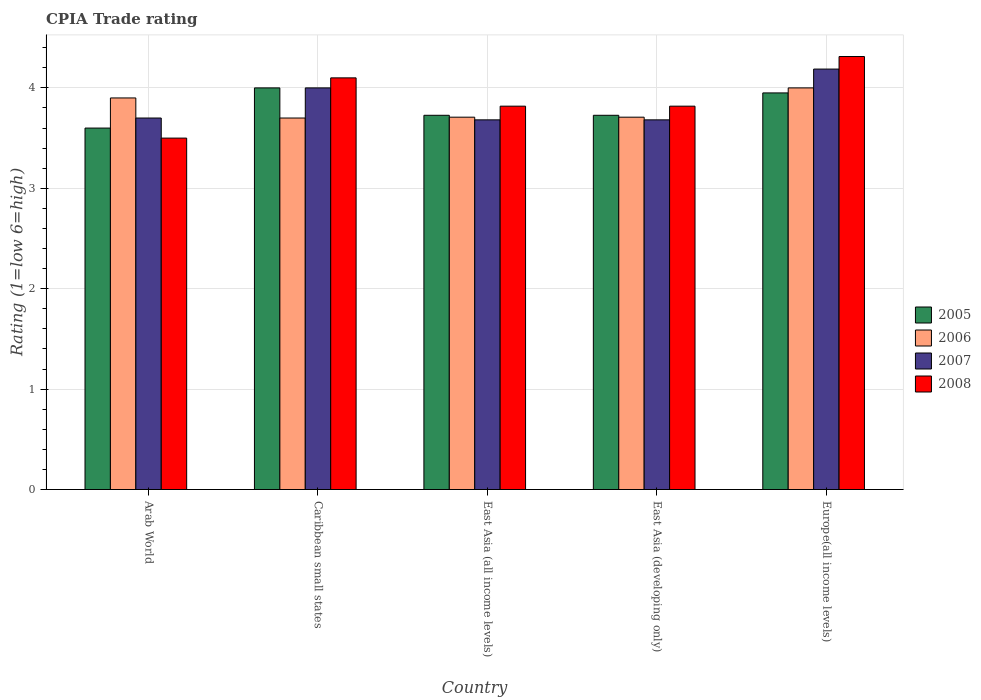How many groups of bars are there?
Offer a very short reply. 5. Are the number of bars on each tick of the X-axis equal?
Give a very brief answer. Yes. What is the label of the 4th group of bars from the left?
Give a very brief answer. East Asia (developing only). Across all countries, what is the minimum CPIA rating in 2007?
Provide a short and direct response. 3.68. In which country was the CPIA rating in 2007 maximum?
Provide a short and direct response. Europe(all income levels). In which country was the CPIA rating in 2008 minimum?
Ensure brevity in your answer.  Arab World. What is the total CPIA rating in 2006 in the graph?
Give a very brief answer. 19.02. What is the difference between the CPIA rating in 2005 in Arab World and that in Caribbean small states?
Keep it short and to the point. -0.4. What is the difference between the CPIA rating in 2008 in East Asia (all income levels) and the CPIA rating in 2007 in Caribbean small states?
Your response must be concise. -0.18. What is the average CPIA rating in 2005 per country?
Keep it short and to the point. 3.8. What is the difference between the CPIA rating of/in 2007 and CPIA rating of/in 2006 in Arab World?
Your answer should be very brief. -0.2. In how many countries, is the CPIA rating in 2006 greater than 3.6?
Keep it short and to the point. 5. What is the ratio of the CPIA rating in 2006 in Caribbean small states to that in Europe(all income levels)?
Offer a terse response. 0.93. Is the CPIA rating in 2007 in East Asia (all income levels) less than that in East Asia (developing only)?
Ensure brevity in your answer.  No. Is the difference between the CPIA rating in 2007 in Arab World and East Asia (developing only) greater than the difference between the CPIA rating in 2006 in Arab World and East Asia (developing only)?
Your response must be concise. No. What is the difference between the highest and the second highest CPIA rating in 2007?
Offer a very short reply. -0.49. What is the difference between the highest and the lowest CPIA rating in 2006?
Provide a succinct answer. 0.3. In how many countries, is the CPIA rating in 2006 greater than the average CPIA rating in 2006 taken over all countries?
Make the answer very short. 2. Is it the case that in every country, the sum of the CPIA rating in 2007 and CPIA rating in 2008 is greater than the sum of CPIA rating in 2005 and CPIA rating in 2006?
Provide a short and direct response. No. Is it the case that in every country, the sum of the CPIA rating in 2005 and CPIA rating in 2008 is greater than the CPIA rating in 2007?
Offer a terse response. Yes. How many bars are there?
Make the answer very short. 20. How many countries are there in the graph?
Offer a terse response. 5. What is the difference between two consecutive major ticks on the Y-axis?
Offer a terse response. 1. Are the values on the major ticks of Y-axis written in scientific E-notation?
Your response must be concise. No. Does the graph contain any zero values?
Provide a succinct answer. No. Does the graph contain grids?
Your response must be concise. Yes. Where does the legend appear in the graph?
Keep it short and to the point. Center right. How are the legend labels stacked?
Your answer should be compact. Vertical. What is the title of the graph?
Keep it short and to the point. CPIA Trade rating. What is the label or title of the Y-axis?
Your answer should be compact. Rating (1=low 6=high). What is the Rating (1=low 6=high) in 2006 in Arab World?
Offer a terse response. 3.9. What is the Rating (1=low 6=high) of 2007 in Caribbean small states?
Your response must be concise. 4. What is the Rating (1=low 6=high) in 2008 in Caribbean small states?
Provide a succinct answer. 4.1. What is the Rating (1=low 6=high) in 2005 in East Asia (all income levels)?
Keep it short and to the point. 3.73. What is the Rating (1=low 6=high) in 2006 in East Asia (all income levels)?
Offer a terse response. 3.71. What is the Rating (1=low 6=high) of 2007 in East Asia (all income levels)?
Your response must be concise. 3.68. What is the Rating (1=low 6=high) of 2008 in East Asia (all income levels)?
Offer a terse response. 3.82. What is the Rating (1=low 6=high) in 2005 in East Asia (developing only)?
Provide a succinct answer. 3.73. What is the Rating (1=low 6=high) of 2006 in East Asia (developing only)?
Provide a short and direct response. 3.71. What is the Rating (1=low 6=high) of 2007 in East Asia (developing only)?
Your answer should be compact. 3.68. What is the Rating (1=low 6=high) of 2008 in East Asia (developing only)?
Give a very brief answer. 3.82. What is the Rating (1=low 6=high) of 2005 in Europe(all income levels)?
Your answer should be compact. 3.95. What is the Rating (1=low 6=high) in 2006 in Europe(all income levels)?
Make the answer very short. 4. What is the Rating (1=low 6=high) of 2007 in Europe(all income levels)?
Your response must be concise. 4.19. What is the Rating (1=low 6=high) in 2008 in Europe(all income levels)?
Offer a very short reply. 4.31. Across all countries, what is the maximum Rating (1=low 6=high) in 2007?
Ensure brevity in your answer.  4.19. Across all countries, what is the maximum Rating (1=low 6=high) of 2008?
Give a very brief answer. 4.31. Across all countries, what is the minimum Rating (1=low 6=high) of 2005?
Ensure brevity in your answer.  3.6. Across all countries, what is the minimum Rating (1=low 6=high) of 2007?
Keep it short and to the point. 3.68. What is the total Rating (1=low 6=high) in 2005 in the graph?
Provide a succinct answer. 19. What is the total Rating (1=low 6=high) in 2006 in the graph?
Your answer should be compact. 19.02. What is the total Rating (1=low 6=high) in 2007 in the graph?
Give a very brief answer. 19.25. What is the total Rating (1=low 6=high) of 2008 in the graph?
Keep it short and to the point. 19.55. What is the difference between the Rating (1=low 6=high) of 2006 in Arab World and that in Caribbean small states?
Provide a short and direct response. 0.2. What is the difference between the Rating (1=low 6=high) in 2005 in Arab World and that in East Asia (all income levels)?
Make the answer very short. -0.13. What is the difference between the Rating (1=low 6=high) of 2006 in Arab World and that in East Asia (all income levels)?
Offer a terse response. 0.19. What is the difference between the Rating (1=low 6=high) of 2007 in Arab World and that in East Asia (all income levels)?
Provide a short and direct response. 0.02. What is the difference between the Rating (1=low 6=high) in 2008 in Arab World and that in East Asia (all income levels)?
Your answer should be compact. -0.32. What is the difference between the Rating (1=low 6=high) in 2005 in Arab World and that in East Asia (developing only)?
Your response must be concise. -0.13. What is the difference between the Rating (1=low 6=high) of 2006 in Arab World and that in East Asia (developing only)?
Make the answer very short. 0.19. What is the difference between the Rating (1=low 6=high) in 2007 in Arab World and that in East Asia (developing only)?
Make the answer very short. 0.02. What is the difference between the Rating (1=low 6=high) in 2008 in Arab World and that in East Asia (developing only)?
Your answer should be compact. -0.32. What is the difference between the Rating (1=low 6=high) in 2005 in Arab World and that in Europe(all income levels)?
Your answer should be compact. -0.35. What is the difference between the Rating (1=low 6=high) in 2006 in Arab World and that in Europe(all income levels)?
Offer a terse response. -0.1. What is the difference between the Rating (1=low 6=high) of 2007 in Arab World and that in Europe(all income levels)?
Your answer should be compact. -0.49. What is the difference between the Rating (1=low 6=high) in 2008 in Arab World and that in Europe(all income levels)?
Ensure brevity in your answer.  -0.81. What is the difference between the Rating (1=low 6=high) of 2005 in Caribbean small states and that in East Asia (all income levels)?
Give a very brief answer. 0.27. What is the difference between the Rating (1=low 6=high) of 2006 in Caribbean small states and that in East Asia (all income levels)?
Your response must be concise. -0.01. What is the difference between the Rating (1=low 6=high) of 2007 in Caribbean small states and that in East Asia (all income levels)?
Keep it short and to the point. 0.32. What is the difference between the Rating (1=low 6=high) of 2008 in Caribbean small states and that in East Asia (all income levels)?
Offer a terse response. 0.28. What is the difference between the Rating (1=low 6=high) of 2005 in Caribbean small states and that in East Asia (developing only)?
Keep it short and to the point. 0.27. What is the difference between the Rating (1=low 6=high) of 2006 in Caribbean small states and that in East Asia (developing only)?
Your answer should be compact. -0.01. What is the difference between the Rating (1=low 6=high) of 2007 in Caribbean small states and that in East Asia (developing only)?
Give a very brief answer. 0.32. What is the difference between the Rating (1=low 6=high) of 2008 in Caribbean small states and that in East Asia (developing only)?
Offer a very short reply. 0.28. What is the difference between the Rating (1=low 6=high) of 2007 in Caribbean small states and that in Europe(all income levels)?
Your answer should be very brief. -0.19. What is the difference between the Rating (1=low 6=high) in 2008 in Caribbean small states and that in Europe(all income levels)?
Provide a succinct answer. -0.21. What is the difference between the Rating (1=low 6=high) of 2005 in East Asia (all income levels) and that in East Asia (developing only)?
Keep it short and to the point. 0. What is the difference between the Rating (1=low 6=high) of 2006 in East Asia (all income levels) and that in East Asia (developing only)?
Your response must be concise. 0. What is the difference between the Rating (1=low 6=high) of 2007 in East Asia (all income levels) and that in East Asia (developing only)?
Provide a succinct answer. 0. What is the difference between the Rating (1=low 6=high) of 2005 in East Asia (all income levels) and that in Europe(all income levels)?
Your answer should be very brief. -0.22. What is the difference between the Rating (1=low 6=high) of 2006 in East Asia (all income levels) and that in Europe(all income levels)?
Give a very brief answer. -0.29. What is the difference between the Rating (1=low 6=high) of 2007 in East Asia (all income levels) and that in Europe(all income levels)?
Your response must be concise. -0.51. What is the difference between the Rating (1=low 6=high) in 2008 in East Asia (all income levels) and that in Europe(all income levels)?
Your response must be concise. -0.49. What is the difference between the Rating (1=low 6=high) in 2005 in East Asia (developing only) and that in Europe(all income levels)?
Your answer should be very brief. -0.22. What is the difference between the Rating (1=low 6=high) of 2006 in East Asia (developing only) and that in Europe(all income levels)?
Your response must be concise. -0.29. What is the difference between the Rating (1=low 6=high) of 2007 in East Asia (developing only) and that in Europe(all income levels)?
Keep it short and to the point. -0.51. What is the difference between the Rating (1=low 6=high) in 2008 in East Asia (developing only) and that in Europe(all income levels)?
Keep it short and to the point. -0.49. What is the difference between the Rating (1=low 6=high) of 2005 in Arab World and the Rating (1=low 6=high) of 2008 in Caribbean small states?
Provide a short and direct response. -0.5. What is the difference between the Rating (1=low 6=high) in 2006 in Arab World and the Rating (1=low 6=high) in 2007 in Caribbean small states?
Offer a very short reply. -0.1. What is the difference between the Rating (1=low 6=high) in 2007 in Arab World and the Rating (1=low 6=high) in 2008 in Caribbean small states?
Your answer should be very brief. -0.4. What is the difference between the Rating (1=low 6=high) in 2005 in Arab World and the Rating (1=low 6=high) in 2006 in East Asia (all income levels)?
Keep it short and to the point. -0.11. What is the difference between the Rating (1=low 6=high) of 2005 in Arab World and the Rating (1=low 6=high) of 2007 in East Asia (all income levels)?
Keep it short and to the point. -0.08. What is the difference between the Rating (1=low 6=high) in 2005 in Arab World and the Rating (1=low 6=high) in 2008 in East Asia (all income levels)?
Keep it short and to the point. -0.22. What is the difference between the Rating (1=low 6=high) of 2006 in Arab World and the Rating (1=low 6=high) of 2007 in East Asia (all income levels)?
Your response must be concise. 0.22. What is the difference between the Rating (1=low 6=high) of 2006 in Arab World and the Rating (1=low 6=high) of 2008 in East Asia (all income levels)?
Provide a succinct answer. 0.08. What is the difference between the Rating (1=low 6=high) in 2007 in Arab World and the Rating (1=low 6=high) in 2008 in East Asia (all income levels)?
Offer a very short reply. -0.12. What is the difference between the Rating (1=low 6=high) of 2005 in Arab World and the Rating (1=low 6=high) of 2006 in East Asia (developing only)?
Your answer should be compact. -0.11. What is the difference between the Rating (1=low 6=high) of 2005 in Arab World and the Rating (1=low 6=high) of 2007 in East Asia (developing only)?
Your answer should be compact. -0.08. What is the difference between the Rating (1=low 6=high) of 2005 in Arab World and the Rating (1=low 6=high) of 2008 in East Asia (developing only)?
Your answer should be very brief. -0.22. What is the difference between the Rating (1=low 6=high) in 2006 in Arab World and the Rating (1=low 6=high) in 2007 in East Asia (developing only)?
Make the answer very short. 0.22. What is the difference between the Rating (1=low 6=high) of 2006 in Arab World and the Rating (1=low 6=high) of 2008 in East Asia (developing only)?
Provide a succinct answer. 0.08. What is the difference between the Rating (1=low 6=high) in 2007 in Arab World and the Rating (1=low 6=high) in 2008 in East Asia (developing only)?
Your answer should be very brief. -0.12. What is the difference between the Rating (1=low 6=high) of 2005 in Arab World and the Rating (1=low 6=high) of 2007 in Europe(all income levels)?
Your answer should be very brief. -0.59. What is the difference between the Rating (1=low 6=high) in 2005 in Arab World and the Rating (1=low 6=high) in 2008 in Europe(all income levels)?
Keep it short and to the point. -0.71. What is the difference between the Rating (1=low 6=high) in 2006 in Arab World and the Rating (1=low 6=high) in 2007 in Europe(all income levels)?
Give a very brief answer. -0.29. What is the difference between the Rating (1=low 6=high) in 2006 in Arab World and the Rating (1=low 6=high) in 2008 in Europe(all income levels)?
Make the answer very short. -0.41. What is the difference between the Rating (1=low 6=high) of 2007 in Arab World and the Rating (1=low 6=high) of 2008 in Europe(all income levels)?
Provide a short and direct response. -0.61. What is the difference between the Rating (1=low 6=high) in 2005 in Caribbean small states and the Rating (1=low 6=high) in 2006 in East Asia (all income levels)?
Offer a terse response. 0.29. What is the difference between the Rating (1=low 6=high) in 2005 in Caribbean small states and the Rating (1=low 6=high) in 2007 in East Asia (all income levels)?
Offer a terse response. 0.32. What is the difference between the Rating (1=low 6=high) in 2005 in Caribbean small states and the Rating (1=low 6=high) in 2008 in East Asia (all income levels)?
Ensure brevity in your answer.  0.18. What is the difference between the Rating (1=low 6=high) in 2006 in Caribbean small states and the Rating (1=low 6=high) in 2007 in East Asia (all income levels)?
Offer a terse response. 0.02. What is the difference between the Rating (1=low 6=high) in 2006 in Caribbean small states and the Rating (1=low 6=high) in 2008 in East Asia (all income levels)?
Provide a succinct answer. -0.12. What is the difference between the Rating (1=low 6=high) of 2007 in Caribbean small states and the Rating (1=low 6=high) of 2008 in East Asia (all income levels)?
Provide a succinct answer. 0.18. What is the difference between the Rating (1=low 6=high) in 2005 in Caribbean small states and the Rating (1=low 6=high) in 2006 in East Asia (developing only)?
Keep it short and to the point. 0.29. What is the difference between the Rating (1=low 6=high) of 2005 in Caribbean small states and the Rating (1=low 6=high) of 2007 in East Asia (developing only)?
Offer a terse response. 0.32. What is the difference between the Rating (1=low 6=high) in 2005 in Caribbean small states and the Rating (1=low 6=high) in 2008 in East Asia (developing only)?
Give a very brief answer. 0.18. What is the difference between the Rating (1=low 6=high) in 2006 in Caribbean small states and the Rating (1=low 6=high) in 2007 in East Asia (developing only)?
Ensure brevity in your answer.  0.02. What is the difference between the Rating (1=low 6=high) in 2006 in Caribbean small states and the Rating (1=low 6=high) in 2008 in East Asia (developing only)?
Offer a very short reply. -0.12. What is the difference between the Rating (1=low 6=high) in 2007 in Caribbean small states and the Rating (1=low 6=high) in 2008 in East Asia (developing only)?
Provide a short and direct response. 0.18. What is the difference between the Rating (1=low 6=high) in 2005 in Caribbean small states and the Rating (1=low 6=high) in 2007 in Europe(all income levels)?
Ensure brevity in your answer.  -0.19. What is the difference between the Rating (1=low 6=high) of 2005 in Caribbean small states and the Rating (1=low 6=high) of 2008 in Europe(all income levels)?
Your answer should be very brief. -0.31. What is the difference between the Rating (1=low 6=high) in 2006 in Caribbean small states and the Rating (1=low 6=high) in 2007 in Europe(all income levels)?
Keep it short and to the point. -0.49. What is the difference between the Rating (1=low 6=high) in 2006 in Caribbean small states and the Rating (1=low 6=high) in 2008 in Europe(all income levels)?
Offer a very short reply. -0.61. What is the difference between the Rating (1=low 6=high) in 2007 in Caribbean small states and the Rating (1=low 6=high) in 2008 in Europe(all income levels)?
Your answer should be compact. -0.31. What is the difference between the Rating (1=low 6=high) of 2005 in East Asia (all income levels) and the Rating (1=low 6=high) of 2006 in East Asia (developing only)?
Give a very brief answer. 0.02. What is the difference between the Rating (1=low 6=high) in 2005 in East Asia (all income levels) and the Rating (1=low 6=high) in 2007 in East Asia (developing only)?
Keep it short and to the point. 0.05. What is the difference between the Rating (1=low 6=high) of 2005 in East Asia (all income levels) and the Rating (1=low 6=high) of 2008 in East Asia (developing only)?
Offer a very short reply. -0.09. What is the difference between the Rating (1=low 6=high) of 2006 in East Asia (all income levels) and the Rating (1=low 6=high) of 2007 in East Asia (developing only)?
Your answer should be compact. 0.03. What is the difference between the Rating (1=low 6=high) in 2006 in East Asia (all income levels) and the Rating (1=low 6=high) in 2008 in East Asia (developing only)?
Ensure brevity in your answer.  -0.11. What is the difference between the Rating (1=low 6=high) in 2007 in East Asia (all income levels) and the Rating (1=low 6=high) in 2008 in East Asia (developing only)?
Ensure brevity in your answer.  -0.14. What is the difference between the Rating (1=low 6=high) of 2005 in East Asia (all income levels) and the Rating (1=low 6=high) of 2006 in Europe(all income levels)?
Provide a short and direct response. -0.27. What is the difference between the Rating (1=low 6=high) in 2005 in East Asia (all income levels) and the Rating (1=low 6=high) in 2007 in Europe(all income levels)?
Keep it short and to the point. -0.46. What is the difference between the Rating (1=low 6=high) of 2005 in East Asia (all income levels) and the Rating (1=low 6=high) of 2008 in Europe(all income levels)?
Offer a very short reply. -0.59. What is the difference between the Rating (1=low 6=high) of 2006 in East Asia (all income levels) and the Rating (1=low 6=high) of 2007 in Europe(all income levels)?
Keep it short and to the point. -0.48. What is the difference between the Rating (1=low 6=high) of 2006 in East Asia (all income levels) and the Rating (1=low 6=high) of 2008 in Europe(all income levels)?
Give a very brief answer. -0.6. What is the difference between the Rating (1=low 6=high) in 2007 in East Asia (all income levels) and the Rating (1=low 6=high) in 2008 in Europe(all income levels)?
Ensure brevity in your answer.  -0.63. What is the difference between the Rating (1=low 6=high) of 2005 in East Asia (developing only) and the Rating (1=low 6=high) of 2006 in Europe(all income levels)?
Provide a succinct answer. -0.27. What is the difference between the Rating (1=low 6=high) in 2005 in East Asia (developing only) and the Rating (1=low 6=high) in 2007 in Europe(all income levels)?
Ensure brevity in your answer.  -0.46. What is the difference between the Rating (1=low 6=high) of 2005 in East Asia (developing only) and the Rating (1=low 6=high) of 2008 in Europe(all income levels)?
Your answer should be very brief. -0.59. What is the difference between the Rating (1=low 6=high) of 2006 in East Asia (developing only) and the Rating (1=low 6=high) of 2007 in Europe(all income levels)?
Offer a terse response. -0.48. What is the difference between the Rating (1=low 6=high) of 2006 in East Asia (developing only) and the Rating (1=low 6=high) of 2008 in Europe(all income levels)?
Offer a very short reply. -0.6. What is the difference between the Rating (1=low 6=high) in 2007 in East Asia (developing only) and the Rating (1=low 6=high) in 2008 in Europe(all income levels)?
Offer a very short reply. -0.63. What is the average Rating (1=low 6=high) of 2005 per country?
Your answer should be compact. 3.8. What is the average Rating (1=low 6=high) of 2006 per country?
Your answer should be very brief. 3.8. What is the average Rating (1=low 6=high) of 2007 per country?
Your answer should be compact. 3.85. What is the average Rating (1=low 6=high) of 2008 per country?
Offer a very short reply. 3.91. What is the difference between the Rating (1=low 6=high) of 2005 and Rating (1=low 6=high) of 2007 in Arab World?
Provide a succinct answer. -0.1. What is the difference between the Rating (1=low 6=high) in 2005 and Rating (1=low 6=high) in 2008 in Arab World?
Make the answer very short. 0.1. What is the difference between the Rating (1=low 6=high) in 2005 and Rating (1=low 6=high) in 2006 in Caribbean small states?
Provide a short and direct response. 0.3. What is the difference between the Rating (1=low 6=high) in 2005 and Rating (1=low 6=high) in 2007 in Caribbean small states?
Offer a terse response. 0. What is the difference between the Rating (1=low 6=high) of 2005 and Rating (1=low 6=high) of 2008 in Caribbean small states?
Provide a short and direct response. -0.1. What is the difference between the Rating (1=low 6=high) in 2006 and Rating (1=low 6=high) in 2008 in Caribbean small states?
Your answer should be compact. -0.4. What is the difference between the Rating (1=low 6=high) of 2007 and Rating (1=low 6=high) of 2008 in Caribbean small states?
Provide a succinct answer. -0.1. What is the difference between the Rating (1=low 6=high) in 2005 and Rating (1=low 6=high) in 2006 in East Asia (all income levels)?
Your answer should be very brief. 0.02. What is the difference between the Rating (1=low 6=high) in 2005 and Rating (1=low 6=high) in 2007 in East Asia (all income levels)?
Provide a succinct answer. 0.05. What is the difference between the Rating (1=low 6=high) of 2005 and Rating (1=low 6=high) of 2008 in East Asia (all income levels)?
Offer a very short reply. -0.09. What is the difference between the Rating (1=low 6=high) in 2006 and Rating (1=low 6=high) in 2007 in East Asia (all income levels)?
Offer a very short reply. 0.03. What is the difference between the Rating (1=low 6=high) of 2006 and Rating (1=low 6=high) of 2008 in East Asia (all income levels)?
Your answer should be compact. -0.11. What is the difference between the Rating (1=low 6=high) of 2007 and Rating (1=low 6=high) of 2008 in East Asia (all income levels)?
Your answer should be compact. -0.14. What is the difference between the Rating (1=low 6=high) of 2005 and Rating (1=low 6=high) of 2006 in East Asia (developing only)?
Provide a succinct answer. 0.02. What is the difference between the Rating (1=low 6=high) in 2005 and Rating (1=low 6=high) in 2007 in East Asia (developing only)?
Your response must be concise. 0.05. What is the difference between the Rating (1=low 6=high) in 2005 and Rating (1=low 6=high) in 2008 in East Asia (developing only)?
Provide a succinct answer. -0.09. What is the difference between the Rating (1=low 6=high) of 2006 and Rating (1=low 6=high) of 2007 in East Asia (developing only)?
Provide a short and direct response. 0.03. What is the difference between the Rating (1=low 6=high) in 2006 and Rating (1=low 6=high) in 2008 in East Asia (developing only)?
Ensure brevity in your answer.  -0.11. What is the difference between the Rating (1=low 6=high) in 2007 and Rating (1=low 6=high) in 2008 in East Asia (developing only)?
Offer a terse response. -0.14. What is the difference between the Rating (1=low 6=high) of 2005 and Rating (1=low 6=high) of 2006 in Europe(all income levels)?
Ensure brevity in your answer.  -0.05. What is the difference between the Rating (1=low 6=high) of 2005 and Rating (1=low 6=high) of 2007 in Europe(all income levels)?
Your answer should be very brief. -0.24. What is the difference between the Rating (1=low 6=high) of 2005 and Rating (1=low 6=high) of 2008 in Europe(all income levels)?
Your response must be concise. -0.36. What is the difference between the Rating (1=low 6=high) in 2006 and Rating (1=low 6=high) in 2007 in Europe(all income levels)?
Make the answer very short. -0.19. What is the difference between the Rating (1=low 6=high) in 2006 and Rating (1=low 6=high) in 2008 in Europe(all income levels)?
Ensure brevity in your answer.  -0.31. What is the difference between the Rating (1=low 6=high) in 2007 and Rating (1=low 6=high) in 2008 in Europe(all income levels)?
Provide a succinct answer. -0.12. What is the ratio of the Rating (1=low 6=high) in 2006 in Arab World to that in Caribbean small states?
Make the answer very short. 1.05. What is the ratio of the Rating (1=low 6=high) of 2007 in Arab World to that in Caribbean small states?
Your response must be concise. 0.93. What is the ratio of the Rating (1=low 6=high) in 2008 in Arab World to that in Caribbean small states?
Give a very brief answer. 0.85. What is the ratio of the Rating (1=low 6=high) in 2005 in Arab World to that in East Asia (all income levels)?
Offer a very short reply. 0.97. What is the ratio of the Rating (1=low 6=high) in 2006 in Arab World to that in East Asia (all income levels)?
Give a very brief answer. 1.05. What is the ratio of the Rating (1=low 6=high) in 2007 in Arab World to that in East Asia (all income levels)?
Your answer should be compact. 1. What is the ratio of the Rating (1=low 6=high) in 2005 in Arab World to that in East Asia (developing only)?
Offer a terse response. 0.97. What is the ratio of the Rating (1=low 6=high) of 2006 in Arab World to that in East Asia (developing only)?
Offer a very short reply. 1.05. What is the ratio of the Rating (1=low 6=high) of 2005 in Arab World to that in Europe(all income levels)?
Make the answer very short. 0.91. What is the ratio of the Rating (1=low 6=high) in 2007 in Arab World to that in Europe(all income levels)?
Make the answer very short. 0.88. What is the ratio of the Rating (1=low 6=high) of 2008 in Arab World to that in Europe(all income levels)?
Your answer should be very brief. 0.81. What is the ratio of the Rating (1=low 6=high) of 2005 in Caribbean small states to that in East Asia (all income levels)?
Offer a terse response. 1.07. What is the ratio of the Rating (1=low 6=high) in 2007 in Caribbean small states to that in East Asia (all income levels)?
Keep it short and to the point. 1.09. What is the ratio of the Rating (1=low 6=high) of 2008 in Caribbean small states to that in East Asia (all income levels)?
Keep it short and to the point. 1.07. What is the ratio of the Rating (1=low 6=high) in 2005 in Caribbean small states to that in East Asia (developing only)?
Make the answer very short. 1.07. What is the ratio of the Rating (1=low 6=high) in 2007 in Caribbean small states to that in East Asia (developing only)?
Offer a terse response. 1.09. What is the ratio of the Rating (1=low 6=high) of 2008 in Caribbean small states to that in East Asia (developing only)?
Ensure brevity in your answer.  1.07. What is the ratio of the Rating (1=low 6=high) of 2005 in Caribbean small states to that in Europe(all income levels)?
Ensure brevity in your answer.  1.01. What is the ratio of the Rating (1=low 6=high) in 2006 in Caribbean small states to that in Europe(all income levels)?
Provide a short and direct response. 0.93. What is the ratio of the Rating (1=low 6=high) of 2007 in Caribbean small states to that in Europe(all income levels)?
Your response must be concise. 0.96. What is the ratio of the Rating (1=low 6=high) of 2008 in Caribbean small states to that in Europe(all income levels)?
Give a very brief answer. 0.95. What is the ratio of the Rating (1=low 6=high) in 2006 in East Asia (all income levels) to that in East Asia (developing only)?
Provide a short and direct response. 1. What is the ratio of the Rating (1=low 6=high) in 2008 in East Asia (all income levels) to that in East Asia (developing only)?
Offer a terse response. 1. What is the ratio of the Rating (1=low 6=high) in 2005 in East Asia (all income levels) to that in Europe(all income levels)?
Provide a short and direct response. 0.94. What is the ratio of the Rating (1=low 6=high) of 2006 in East Asia (all income levels) to that in Europe(all income levels)?
Keep it short and to the point. 0.93. What is the ratio of the Rating (1=low 6=high) in 2007 in East Asia (all income levels) to that in Europe(all income levels)?
Offer a terse response. 0.88. What is the ratio of the Rating (1=low 6=high) in 2008 in East Asia (all income levels) to that in Europe(all income levels)?
Provide a short and direct response. 0.89. What is the ratio of the Rating (1=low 6=high) in 2005 in East Asia (developing only) to that in Europe(all income levels)?
Your answer should be very brief. 0.94. What is the ratio of the Rating (1=low 6=high) in 2006 in East Asia (developing only) to that in Europe(all income levels)?
Your answer should be very brief. 0.93. What is the ratio of the Rating (1=low 6=high) of 2007 in East Asia (developing only) to that in Europe(all income levels)?
Your response must be concise. 0.88. What is the ratio of the Rating (1=low 6=high) in 2008 in East Asia (developing only) to that in Europe(all income levels)?
Give a very brief answer. 0.89. What is the difference between the highest and the second highest Rating (1=low 6=high) in 2005?
Your response must be concise. 0.05. What is the difference between the highest and the second highest Rating (1=low 6=high) of 2006?
Your response must be concise. 0.1. What is the difference between the highest and the second highest Rating (1=low 6=high) in 2007?
Provide a short and direct response. 0.19. What is the difference between the highest and the second highest Rating (1=low 6=high) in 2008?
Provide a short and direct response. 0.21. What is the difference between the highest and the lowest Rating (1=low 6=high) of 2006?
Provide a short and direct response. 0.3. What is the difference between the highest and the lowest Rating (1=low 6=high) of 2007?
Provide a succinct answer. 0.51. What is the difference between the highest and the lowest Rating (1=low 6=high) in 2008?
Provide a succinct answer. 0.81. 